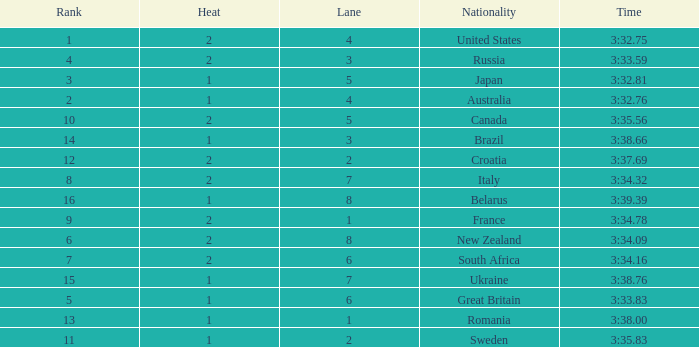Can you tell me the Rank that has the Lane of 6, and the Heat of 2? 7.0. 